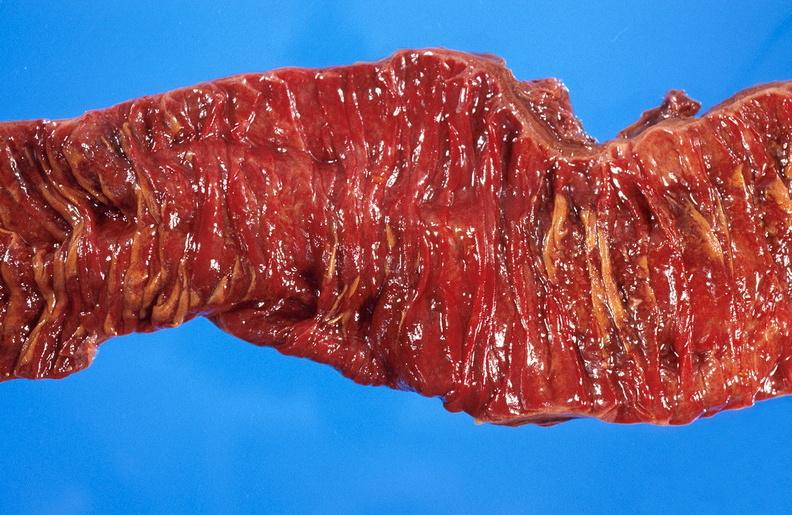does this image show ischemic bowel?
Answer the question using a single word or phrase. Yes 